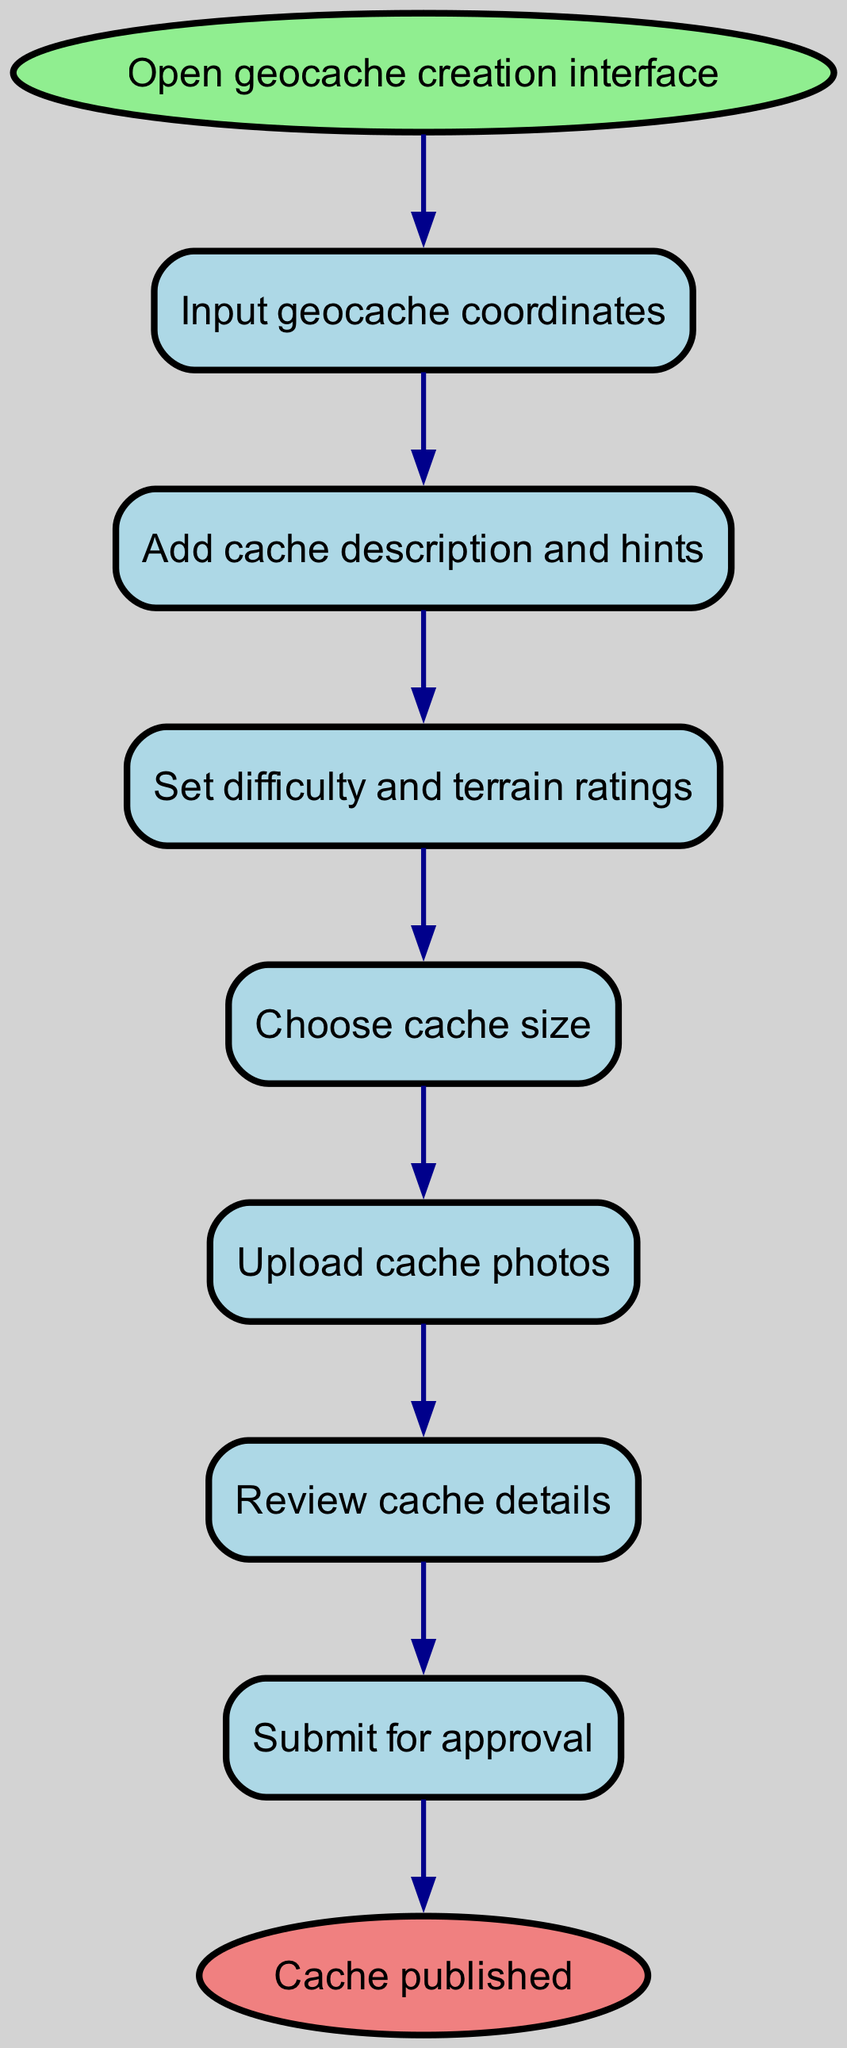What is the first step in the geocache creation process? The first step in the diagram is represented by the node labeled "Open geocache creation interface." This node indicates the starting point of the process.
Answer: Open geocache creation interface How many nodes are present in the flow chart? By counting each distinct node in the diagram, we find a total of eight nodes that represent various steps in the geocache creation process.
Answer: Eight What is the last step before the submission? The last step before the "Submit for approval" step is "Review cache details." This indicates that all details are reviewed just before submission.
Answer: Review cache details What follows the setting of difficulty and terrain ratings? After the "Set difficulty and terrain ratings" step, the next step in the diagram is "Choose cache size." This shows the flow from one task to the next.
Answer: Choose cache size What is the connection between uploading cache photos and reviewing cache details? The connection is that the "Upload cache photos" step directly leads to the "Review cache details" step, indicating that photos must be uploaded before reviewing the details.
Answer: Upload cache photos leads to Review cache details How many steps are required to get from opening the interface to publishing the cache? Following the flow from "Open geocache creation interface" to "Cache published," there are seven steps involved in this process.
Answer: Seven Where does the input of geocache coordinates fit into the overall process? The input of geocache coordinates is the second step in the process, following the opening of the geocache creation interface, emphasizing its importance early in the workflow.
Answer: Input geocache coordinates What step takes place right after choosing the cache size? The next step that follows "Choose cache size" is "Upload cache photos," signaling that after specifying the size, photos can be added subsequently.
Answer: Upload cache photos What type of diagram is represented here? This diagram is a flow chart that illustrates the sequential instruction steps involved in creating and submitting a geocache.
Answer: Flow chart 